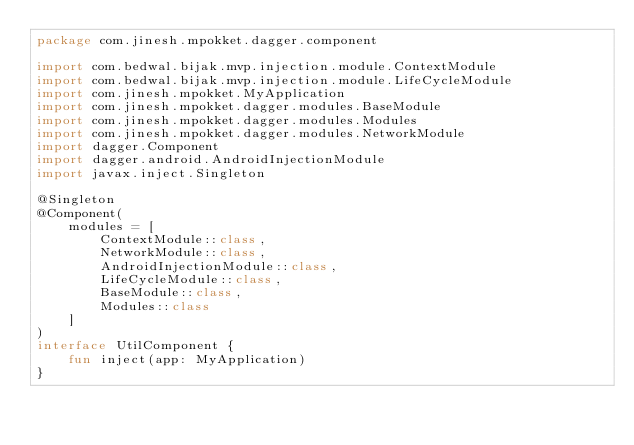<code> <loc_0><loc_0><loc_500><loc_500><_Kotlin_>package com.jinesh.mpokket.dagger.component

import com.bedwal.bijak.mvp.injection.module.ContextModule
import com.bedwal.bijak.mvp.injection.module.LifeCycleModule
import com.jinesh.mpokket.MyApplication
import com.jinesh.mpokket.dagger.modules.BaseModule
import com.jinesh.mpokket.dagger.modules.Modules
import com.jinesh.mpokket.dagger.modules.NetworkModule
import dagger.Component
import dagger.android.AndroidInjectionModule
import javax.inject.Singleton

@Singleton
@Component(
    modules = [
        ContextModule::class,
        NetworkModule::class,
        AndroidInjectionModule::class,
        LifeCycleModule::class,
        BaseModule::class,
        Modules::class
    ]
)
interface UtilComponent {
    fun inject(app: MyApplication)
}</code> 